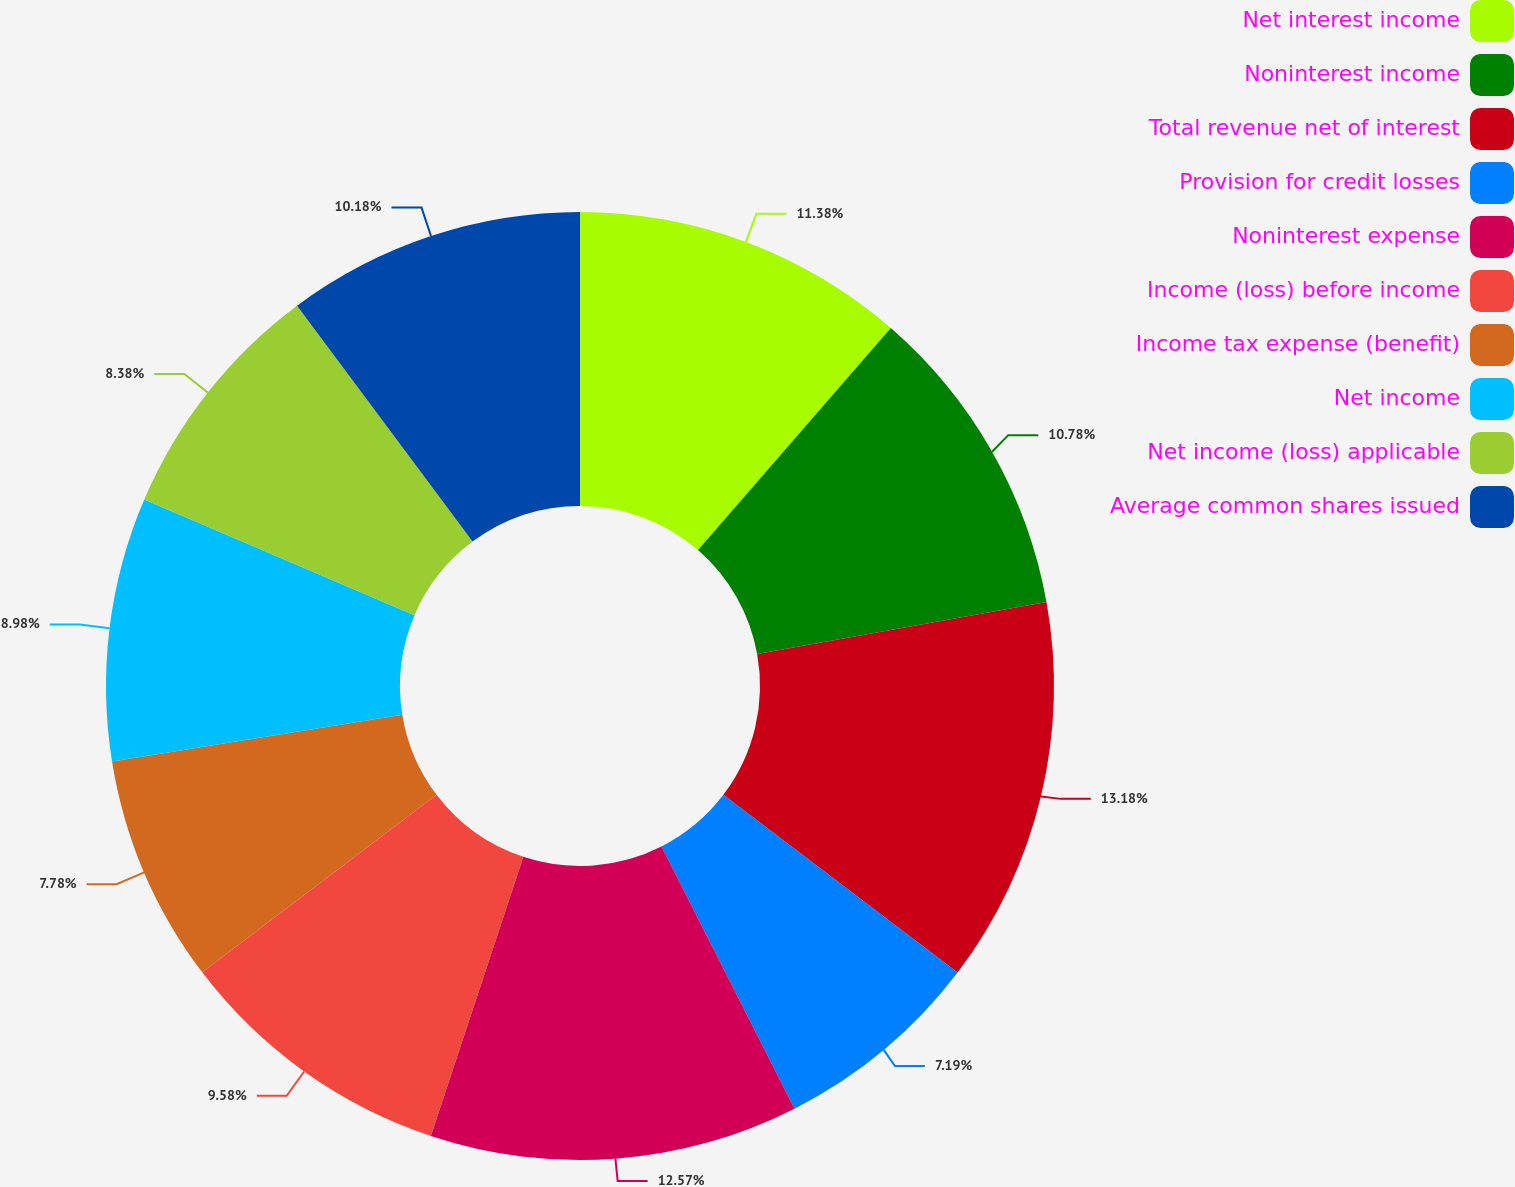<chart> <loc_0><loc_0><loc_500><loc_500><pie_chart><fcel>Net interest income<fcel>Noninterest income<fcel>Total revenue net of interest<fcel>Provision for credit losses<fcel>Noninterest expense<fcel>Income (loss) before income<fcel>Income tax expense (benefit)<fcel>Net income<fcel>Net income (loss) applicable<fcel>Average common shares issued<nl><fcel>11.38%<fcel>10.78%<fcel>13.17%<fcel>7.19%<fcel>12.57%<fcel>9.58%<fcel>7.78%<fcel>8.98%<fcel>8.38%<fcel>10.18%<nl></chart> 